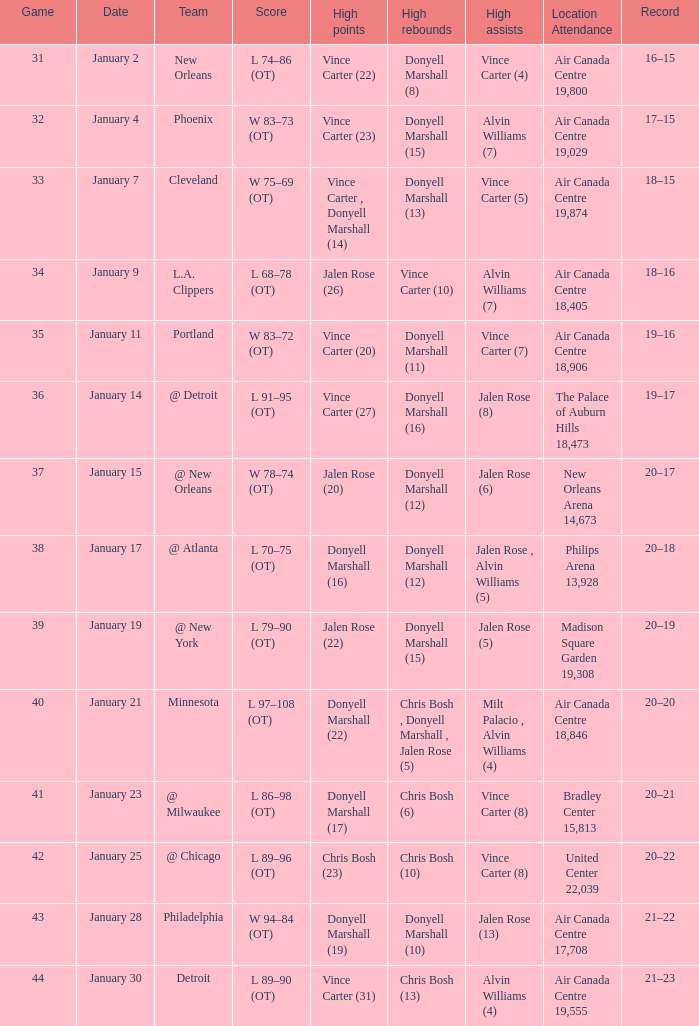Where was the game, and how many attended the game on january 2? Air Canada Centre 19,800. 